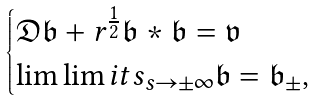<formula> <loc_0><loc_0><loc_500><loc_500>\begin{cases} \mathfrak { D } \mathfrak { b } + r ^ { \frac { 1 } { 2 } } \mathfrak { b } * \mathfrak { b } = \mathfrak { v } \\ \lim \lim i t s _ { s \to \pm \infty } \mathfrak { b } = \mathfrak { b } _ { \pm } , \\ \end{cases}</formula> 